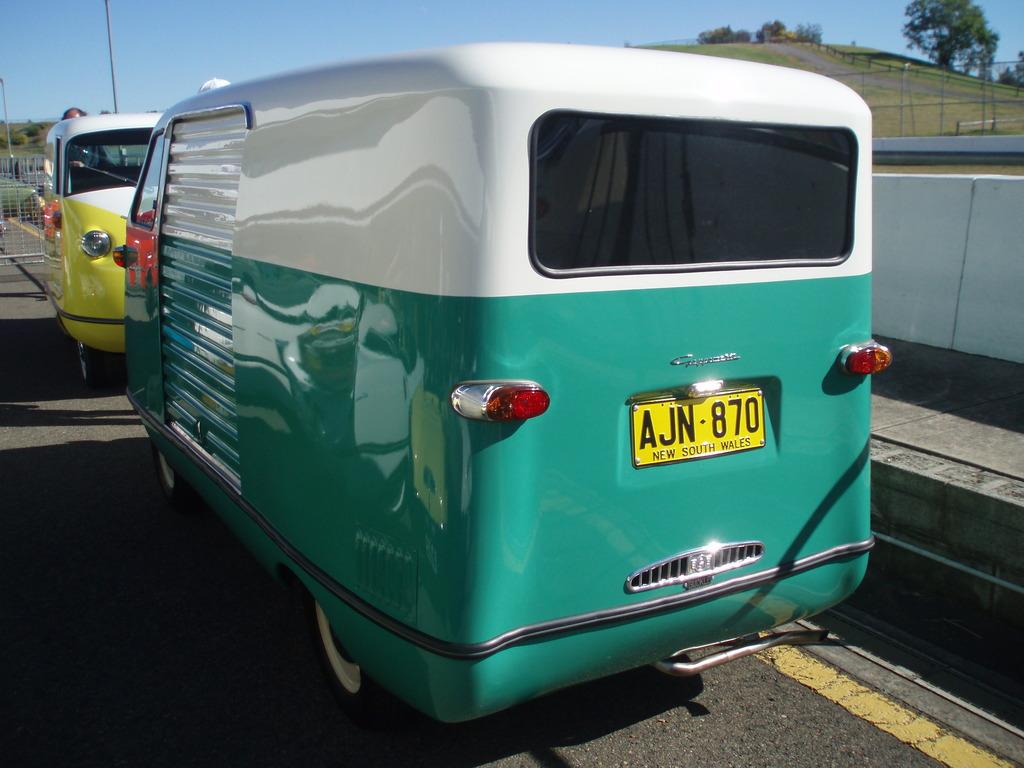What is the licence plate numer?
Ensure brevity in your answer.  Ajn 870. Where is this car?
Your response must be concise. New south wales. 